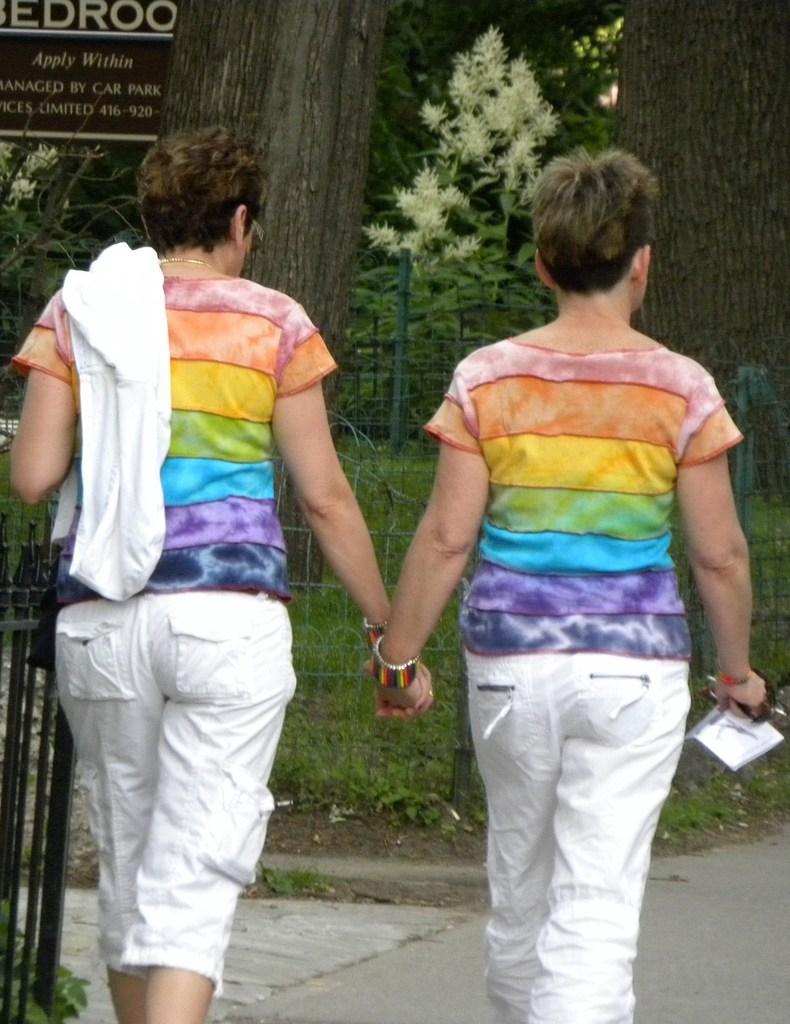Could you give a brief overview of what you see in this image? This image is taken outdoors. At the bottom of the image there is a road. In the background there are many trees and plants on the ground. There is a ground with grass on it. There is a mesh. On the left side of the image there is a railing and there is a board with the text on it. In the middle of the image two persons are walking on the road. 